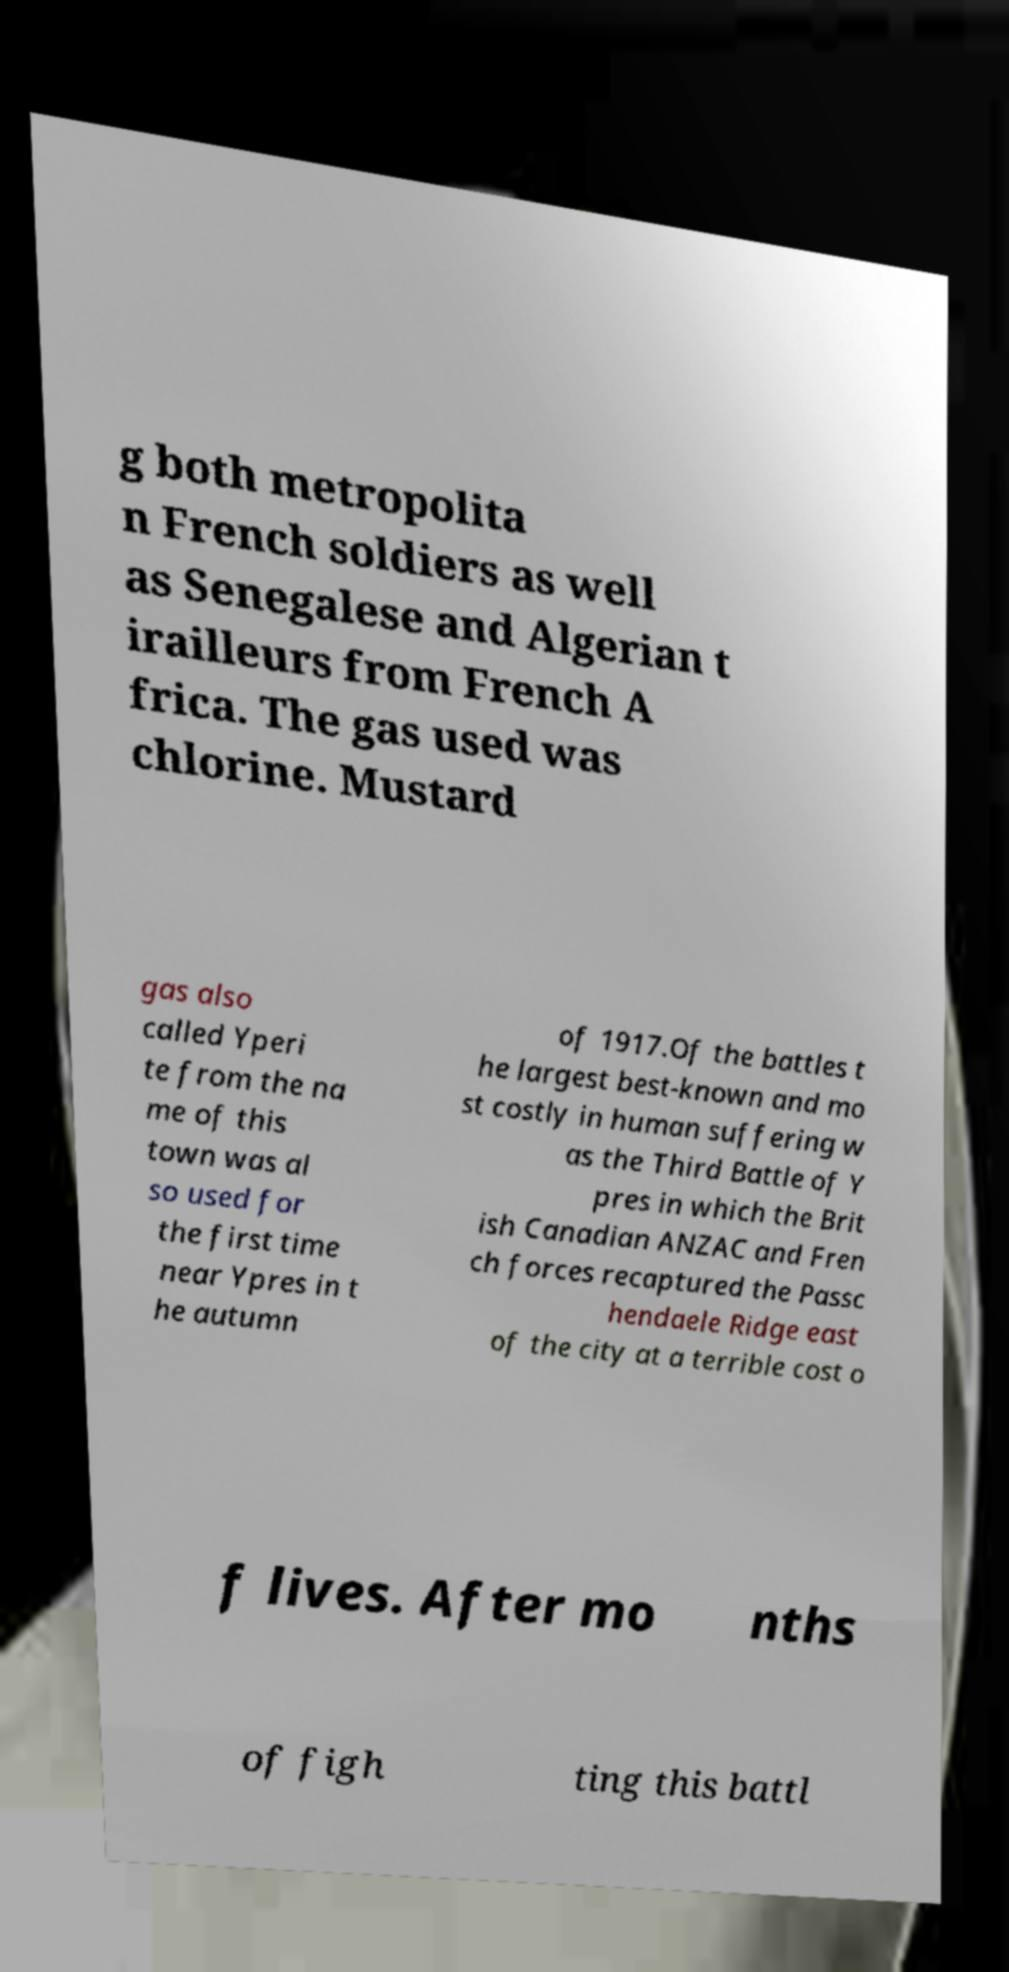Can you read and provide the text displayed in the image?This photo seems to have some interesting text. Can you extract and type it out for me? g both metropolita n French soldiers as well as Senegalese and Algerian t irailleurs from French A frica. The gas used was chlorine. Mustard gas also called Yperi te from the na me of this town was al so used for the first time near Ypres in t he autumn of 1917.Of the battles t he largest best-known and mo st costly in human suffering w as the Third Battle of Y pres in which the Brit ish Canadian ANZAC and Fren ch forces recaptured the Passc hendaele Ridge east of the city at a terrible cost o f lives. After mo nths of figh ting this battl 